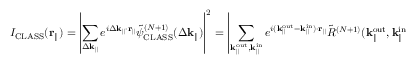<formula> <loc_0><loc_0><loc_500><loc_500>I _ { C L A S S } ( r _ { \| } ) = \left | \sum _ { \Delta k _ { \| } } e ^ { i \Delta k _ { \| } \cdot r _ { \| } } \tilde { \psi } _ { C L A S S } ^ { ( N + 1 ) } ( \Delta k _ { \| } ) \right | ^ { 2 } = \left | \sum _ { k _ { \| } ^ { o u t } , k _ { \| } ^ { i n } } e ^ { i ( k _ { \| } ^ { o u t } - k _ { \| } ^ { i n } ) \cdot r _ { \| } } \tilde { R } ^ { ( N + 1 ) } ( { k _ { \| } ^ { o u t } } , k _ { \| } ^ { i n } ) \right | ^ { 2 } .</formula> 